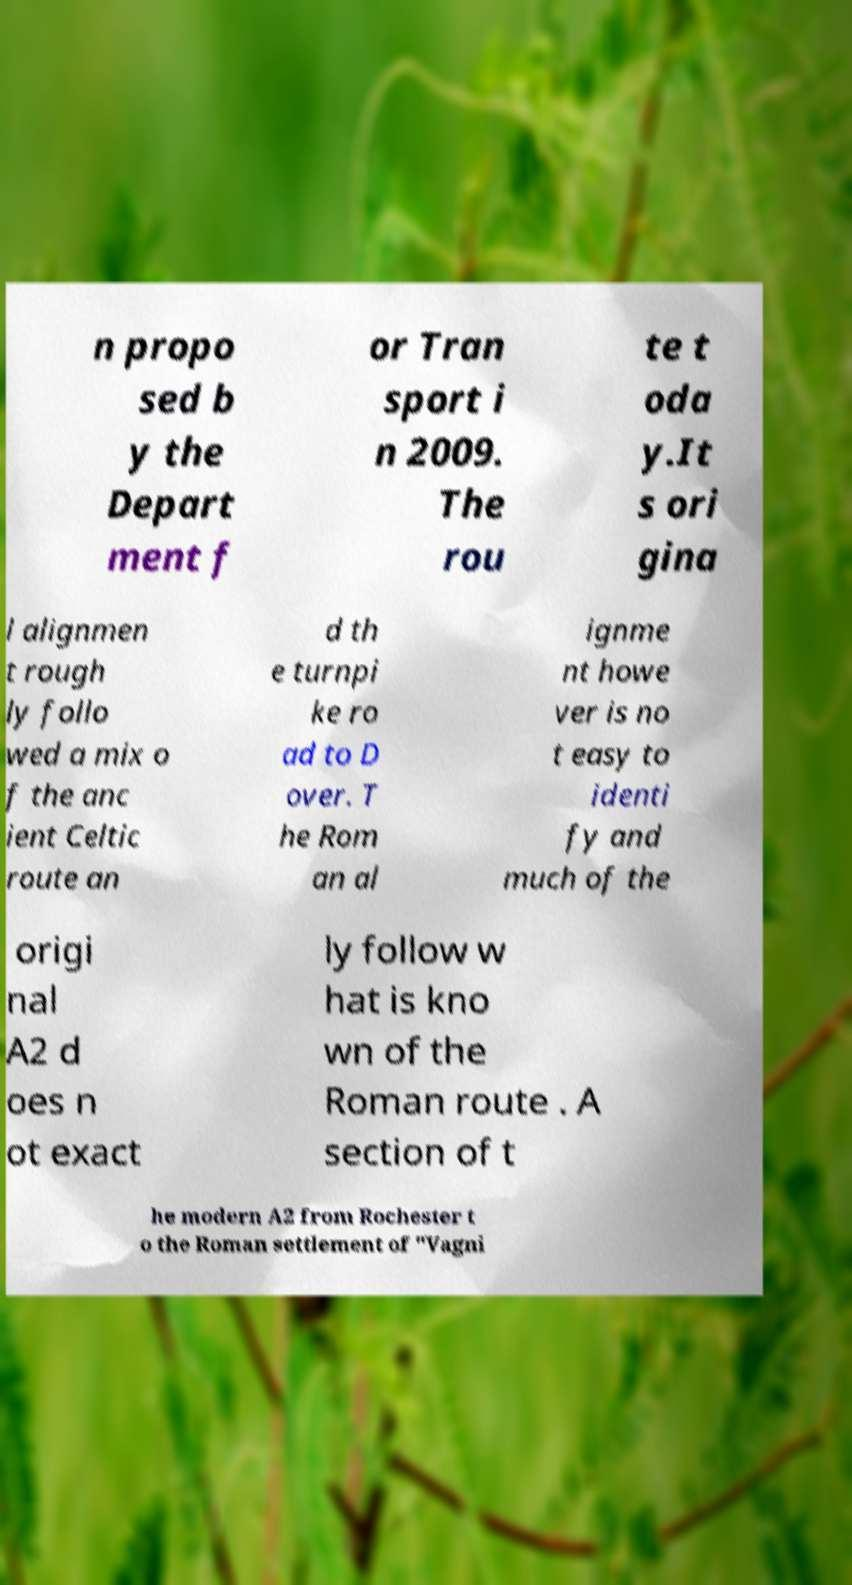Can you read and provide the text displayed in the image?This photo seems to have some interesting text. Can you extract and type it out for me? n propo sed b y the Depart ment f or Tran sport i n 2009. The rou te t oda y.It s ori gina l alignmen t rough ly follo wed a mix o f the anc ient Celtic route an d th e turnpi ke ro ad to D over. T he Rom an al ignme nt howe ver is no t easy to identi fy and much of the origi nal A2 d oes n ot exact ly follow w hat is kno wn of the Roman route . A section of t he modern A2 from Rochester t o the Roman settlement of "Vagni 